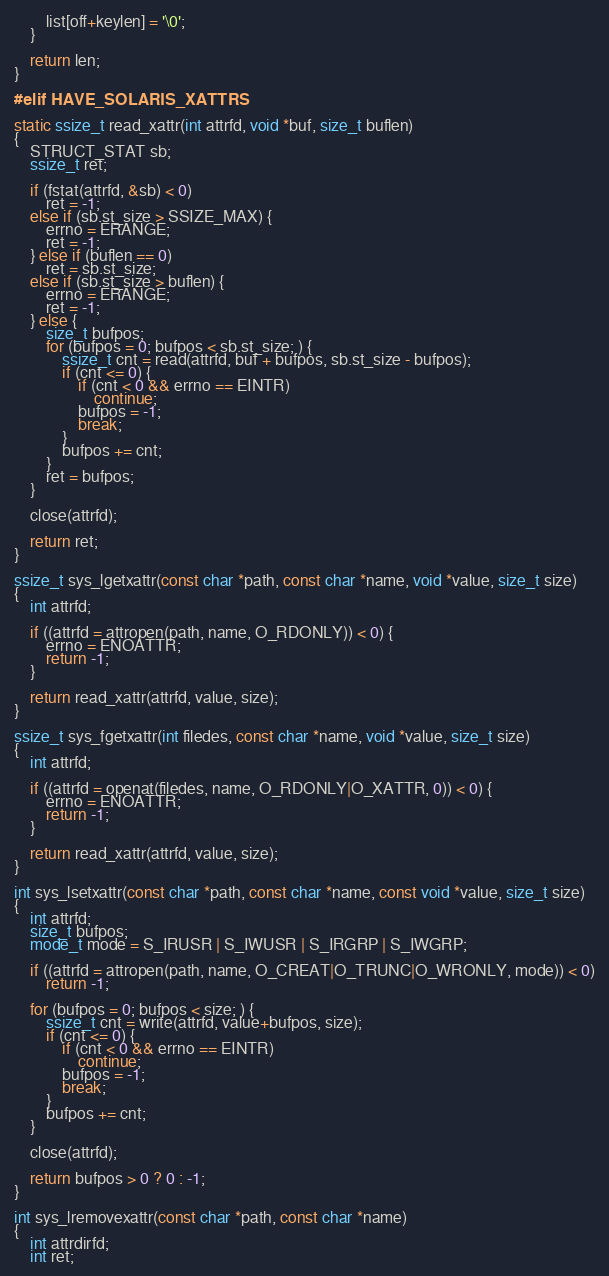<code> <loc_0><loc_0><loc_500><loc_500><_C_>		list[off+keylen] = '\0';
	}

	return len;
}

#elif HAVE_SOLARIS_XATTRS

static ssize_t read_xattr(int attrfd, void *buf, size_t buflen)
{
	STRUCT_STAT sb;
	ssize_t ret;

	if (fstat(attrfd, &sb) < 0)
		ret = -1;
	else if (sb.st_size > SSIZE_MAX) {
		errno = ERANGE;
		ret = -1;
	} else if (buflen == 0)
		ret = sb.st_size;
	else if (sb.st_size > buflen) {
		errno = ERANGE;
		ret = -1;
	} else {
		size_t bufpos;
		for (bufpos = 0; bufpos < sb.st_size; ) {
			ssize_t cnt = read(attrfd, buf + bufpos, sb.st_size - bufpos);
			if (cnt <= 0) {
				if (cnt < 0 && errno == EINTR)
					continue;
				bufpos = -1;
				break;
			}
			bufpos += cnt;
		}
		ret = bufpos;
	}

	close(attrfd);

	return ret;
}

ssize_t sys_lgetxattr(const char *path, const char *name, void *value, size_t size)
{
	int attrfd;

	if ((attrfd = attropen(path, name, O_RDONLY)) < 0) {
		errno = ENOATTR;
		return -1;
	}

	return read_xattr(attrfd, value, size);
}

ssize_t sys_fgetxattr(int filedes, const char *name, void *value, size_t size)
{
	int attrfd;

	if ((attrfd = openat(filedes, name, O_RDONLY|O_XATTR, 0)) < 0) {
		errno = ENOATTR;
		return -1;
	}

	return read_xattr(attrfd, value, size);
}

int sys_lsetxattr(const char *path, const char *name, const void *value, size_t size)
{
	int attrfd;
	size_t bufpos;
	mode_t mode = S_IRUSR | S_IWUSR | S_IRGRP | S_IWGRP;

	if ((attrfd = attropen(path, name, O_CREAT|O_TRUNC|O_WRONLY, mode)) < 0)
		return -1;

	for (bufpos = 0; bufpos < size; ) {
		ssize_t cnt = write(attrfd, value+bufpos, size);
		if (cnt <= 0) {
			if (cnt < 0 && errno == EINTR)
				continue;
			bufpos = -1;
			break;
		}
		bufpos += cnt;
	}

	close(attrfd);

	return bufpos > 0 ? 0 : -1;
}

int sys_lremovexattr(const char *path, const char *name)
{
	int attrdirfd;
	int ret;
</code> 